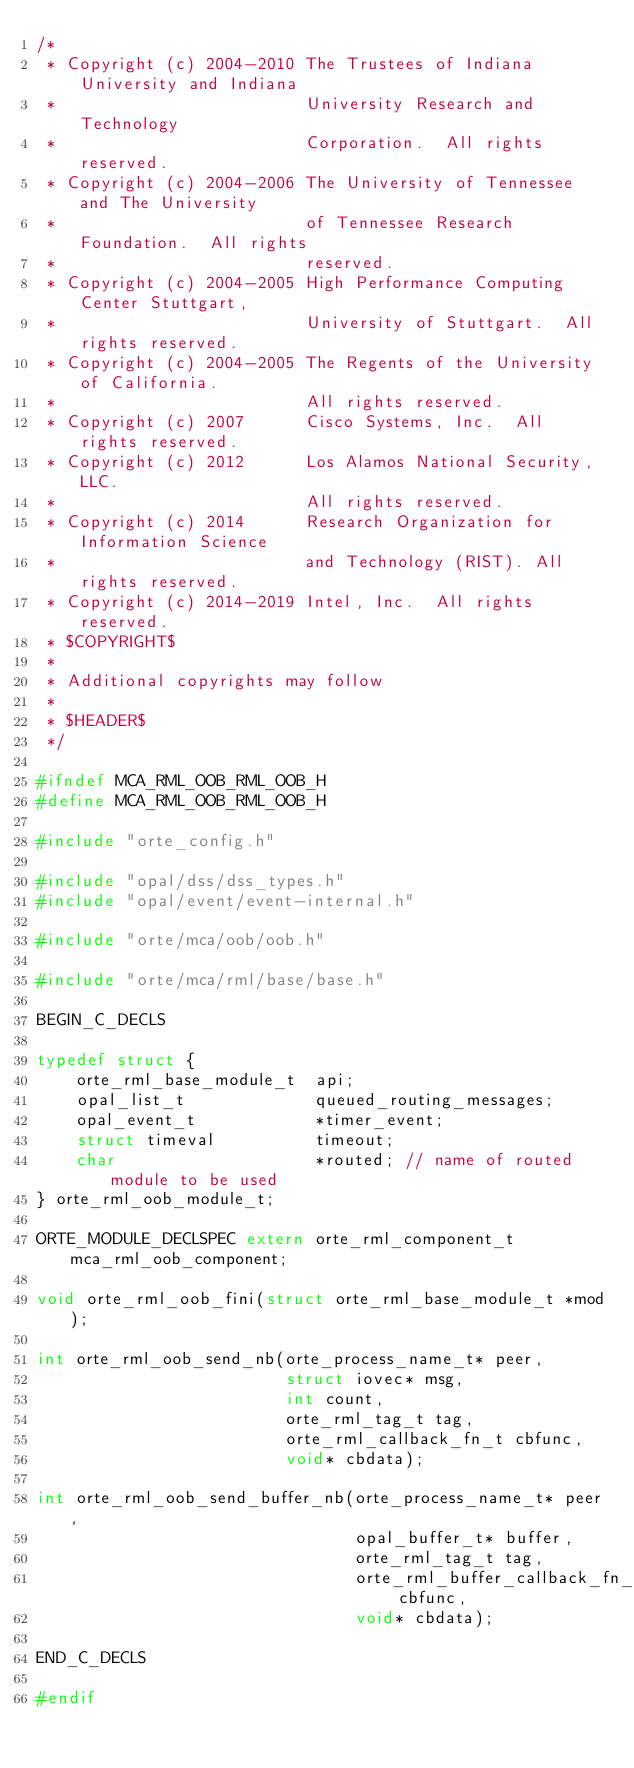<code> <loc_0><loc_0><loc_500><loc_500><_C_>/*
 * Copyright (c) 2004-2010 The Trustees of Indiana University and Indiana
 *                         University Research and Technology
 *                         Corporation.  All rights reserved.
 * Copyright (c) 2004-2006 The University of Tennessee and The University
 *                         of Tennessee Research Foundation.  All rights
 *                         reserved.
 * Copyright (c) 2004-2005 High Performance Computing Center Stuttgart,
 *                         University of Stuttgart.  All rights reserved.
 * Copyright (c) 2004-2005 The Regents of the University of California.
 *                         All rights reserved.
 * Copyright (c) 2007      Cisco Systems, Inc.  All rights reserved.
 * Copyright (c) 2012      Los Alamos National Security, LLC.
 *                         All rights reserved.
 * Copyright (c) 2014      Research Organization for Information Science
 *                         and Technology (RIST). All rights reserved.
 * Copyright (c) 2014-2019 Intel, Inc.  All rights reserved.
 * $COPYRIGHT$
 *
 * Additional copyrights may follow
 *
 * $HEADER$
 */

#ifndef MCA_RML_OOB_RML_OOB_H
#define MCA_RML_OOB_RML_OOB_H

#include "orte_config.h"

#include "opal/dss/dss_types.h"
#include "opal/event/event-internal.h"

#include "orte/mca/oob/oob.h"

#include "orte/mca/rml/base/base.h"

BEGIN_C_DECLS

typedef struct {
    orte_rml_base_module_t  api;
    opal_list_t             queued_routing_messages;
    opal_event_t            *timer_event;
    struct timeval          timeout;
    char                    *routed; // name of routed module to be used
} orte_rml_oob_module_t;

ORTE_MODULE_DECLSPEC extern orte_rml_component_t mca_rml_oob_component;

void orte_rml_oob_fini(struct orte_rml_base_module_t *mod);

int orte_rml_oob_send_nb(orte_process_name_t* peer,
                         struct iovec* msg,
                         int count,
                         orte_rml_tag_t tag,
                         orte_rml_callback_fn_t cbfunc,
                         void* cbdata);

int orte_rml_oob_send_buffer_nb(orte_process_name_t* peer,
                                opal_buffer_t* buffer,
                                orte_rml_tag_t tag,
                                orte_rml_buffer_callback_fn_t cbfunc,
                                void* cbdata);

END_C_DECLS

#endif
</code> 